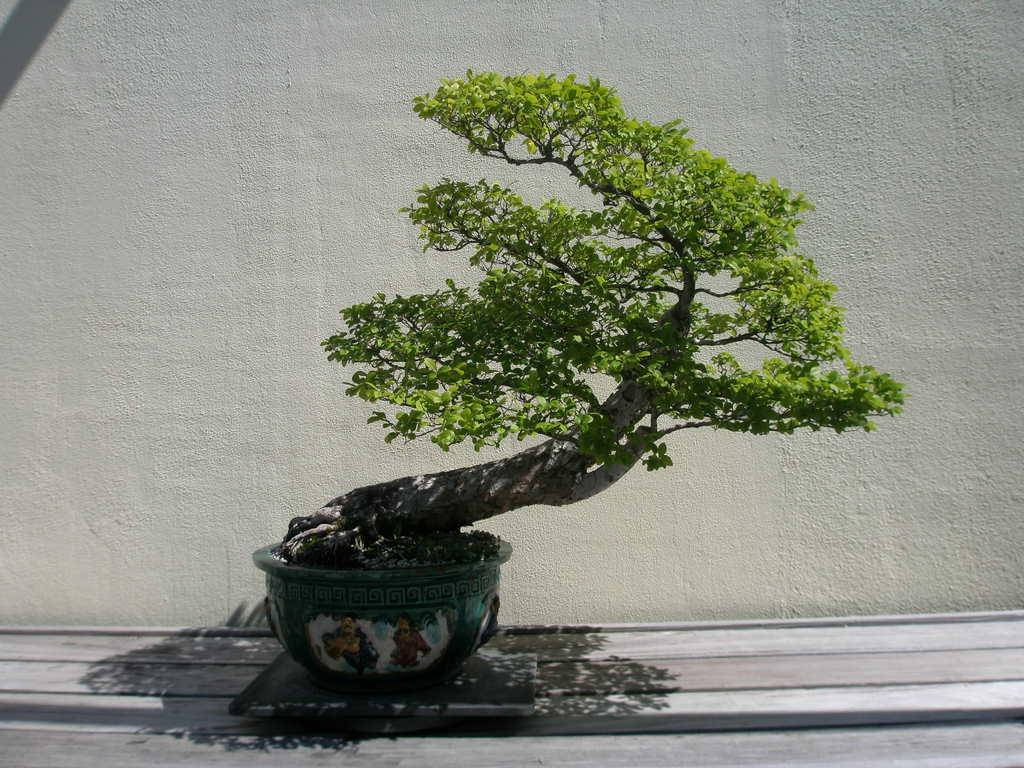What type of plant is in the image? There is a houseplant in the image. Where is the houseplant located? The houseplant is on a surface. What can be seen behind the houseplant? There is a wall visible behind the houseplant. What type of ship can be seen sailing in the image? There is no ship present in the image; it features a houseplant on a surface with a wall visible behind it. 